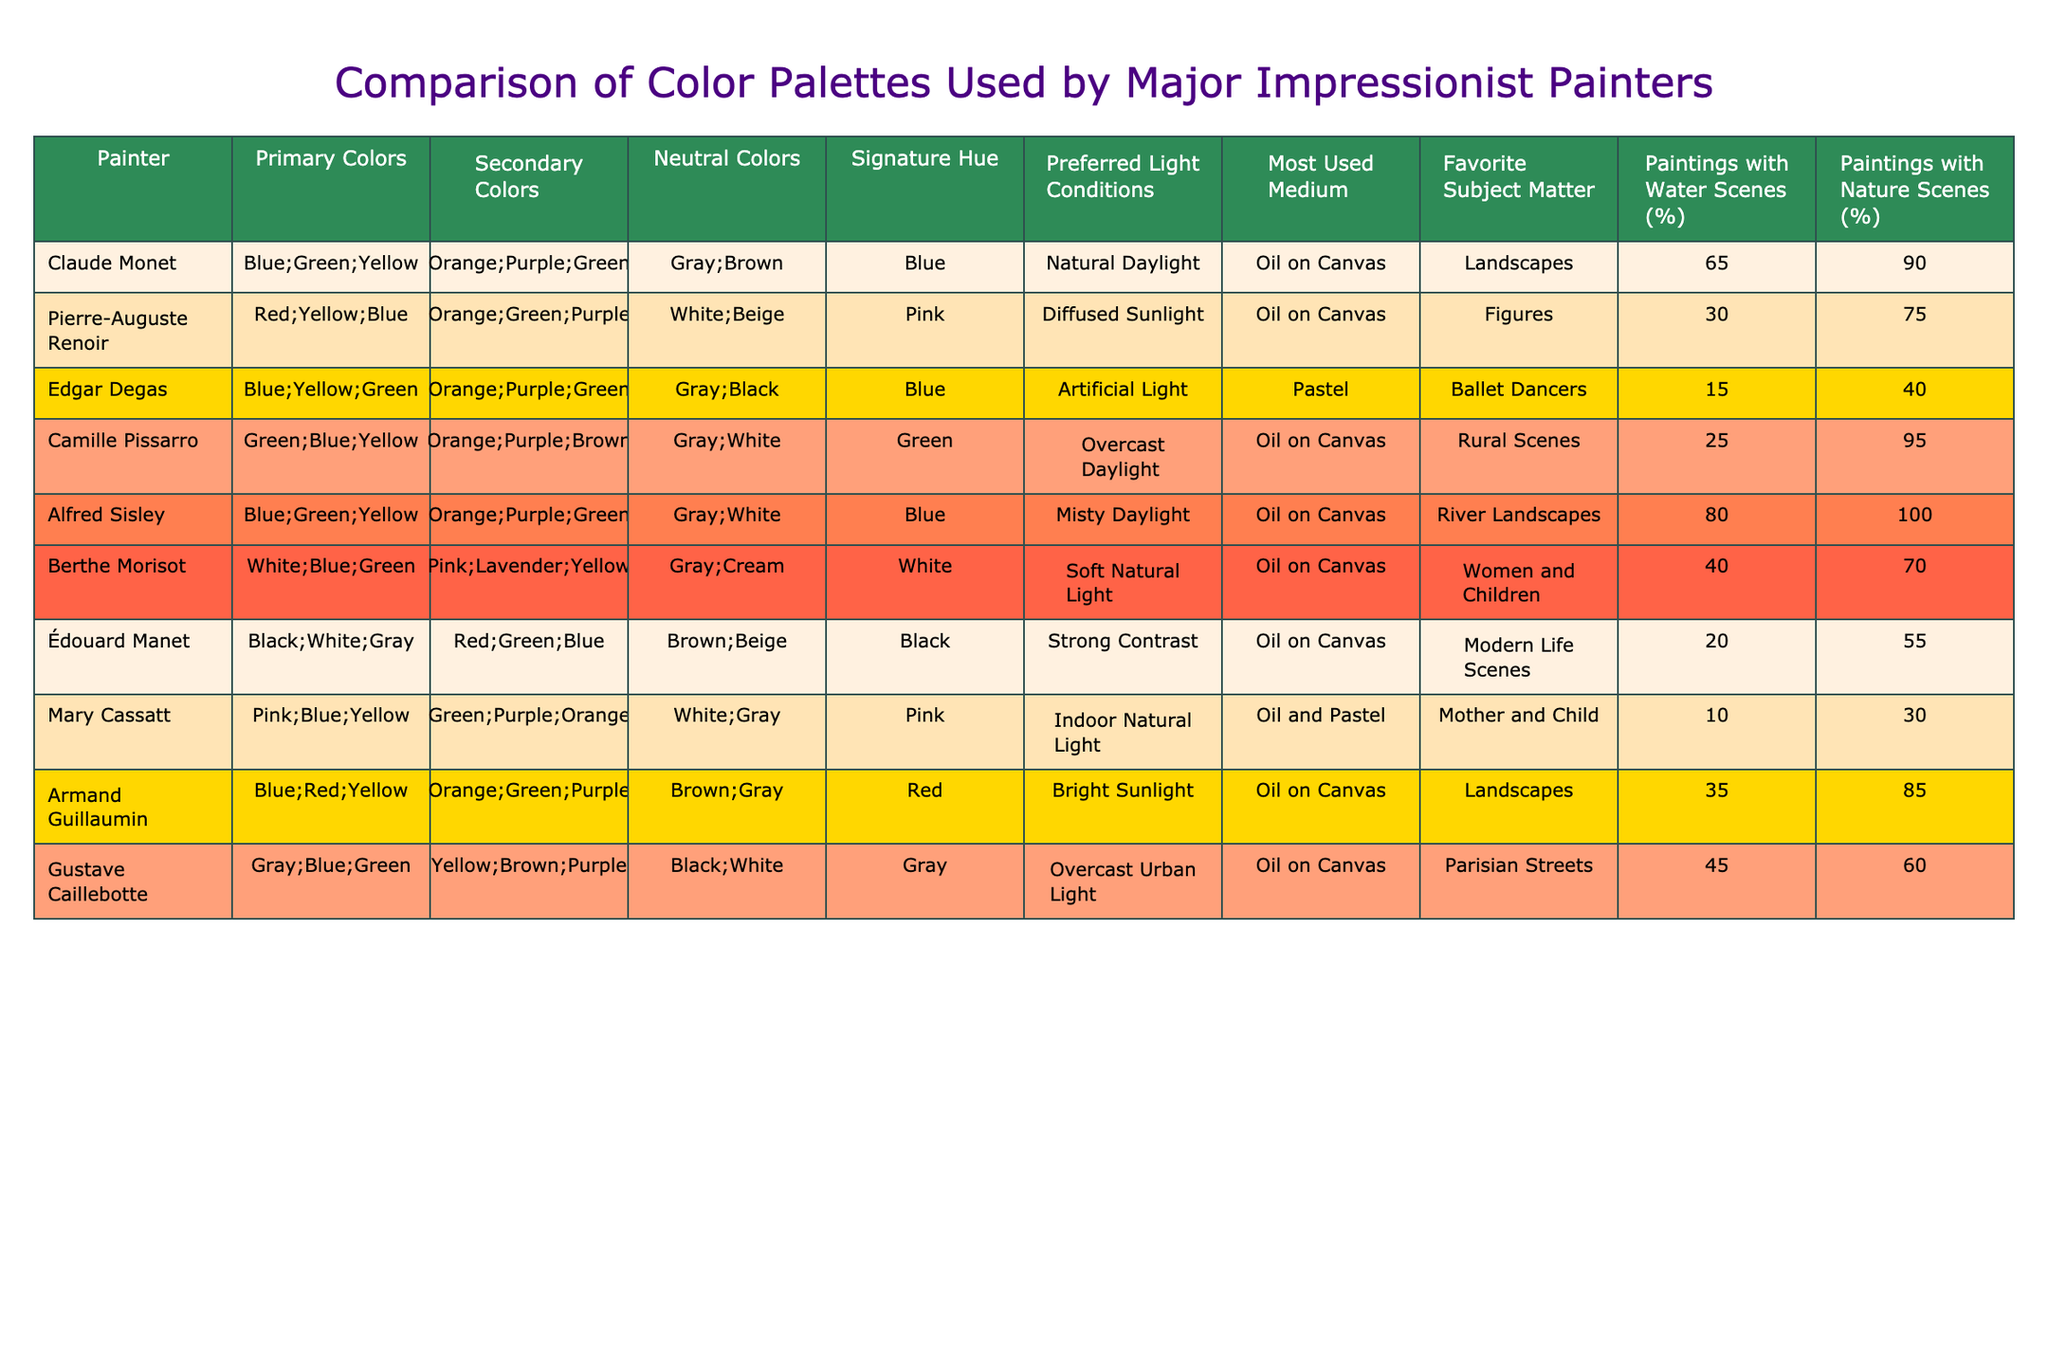What are the primary colors used by Edgar Degas? The primary colors for Edgar Degas, according to the table, are Blue, Yellow, and Green.
Answer: Blue; Yellow; Green Which painter has the highest percentage of paintings that include water scenes? Alfred Sisley has the highest percentage of paintings with water scenes at 80%.
Answer: 80% What is the preferred light condition for Pierre-Auguste Renoir? Pierre-Auguste Renoir prefers diffused sunlight as his light condition for painting.
Answer: Diffused sunlight Which artist predominantly focused on ballet dancers? Edgar Degas predominantly focused on ballet dancers.
Answer: Edgar Degas Calculate the average percentage of paintings with nature scenes among all artists listed. First, we sum the percentages of paintings with nature scenes: 90 + 75 + 40 + 95 + 100 + 70 + 55 + 30 + 85 + 60 = 800. Then we divide by the number of artists (10): 800/10 = 80.
Answer: 80% Is it true that all painters used oil on canvas as their most used medium? It is false; while most artists used oil on canvas, Mary Cassatt used both oil and pastel as her primary medium.
Answer: False Which painter has the signature hue identified as Pink? Berthe Morisot has Pink as her signature hue.
Answer: Berthe Morisot How many painters used green as a primary color? There are four painters who used Green as a primary color: Claude Monet, Edgar Degas, Camille Pissarro, and Alfred Sisley.
Answer: 4 Which painter's work is characterized by using strong contrast? Édouard Manet's work is characterized by using strong contrast.
Answer: Édouard Manet What is the most common subject matter among the given painters? The most common subject matter is landscapes, as indicated by several painters including Claude Monet, Alfred Sisley, and Camille Pissarro.
Answer: Landscapes 